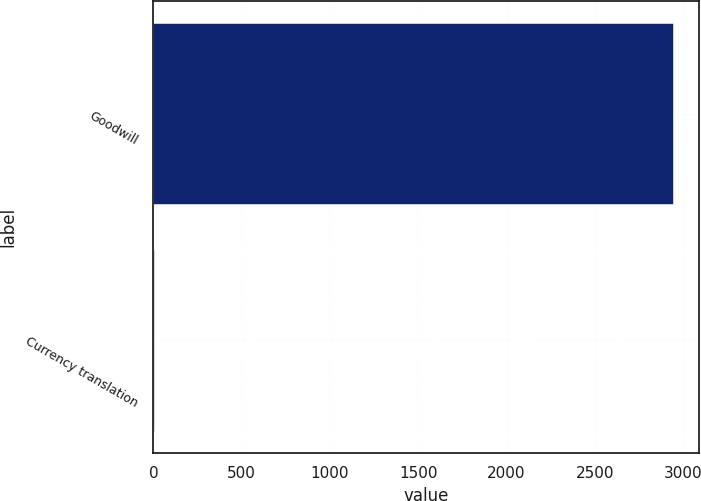Convert chart. <chart><loc_0><loc_0><loc_500><loc_500><bar_chart><fcel>Goodwill<fcel>Currency translation<nl><fcel>2944.8<fcel>4.4<nl></chart> 